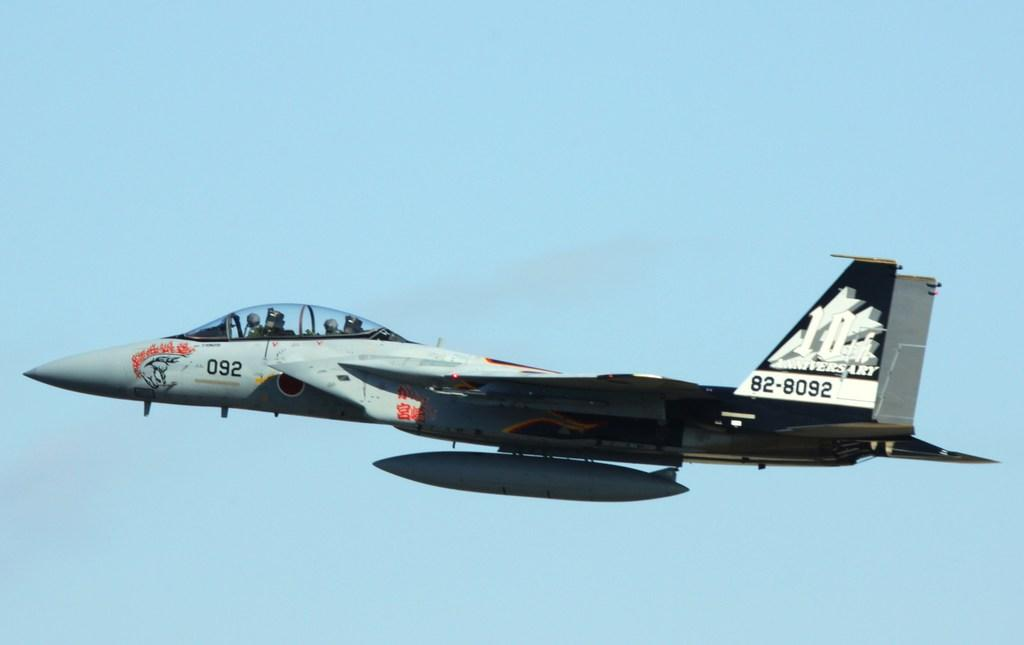<image>
Share a concise interpretation of the image provided. A fighter jet is flying through the sky with the numbers 82-8092 written on its tail 